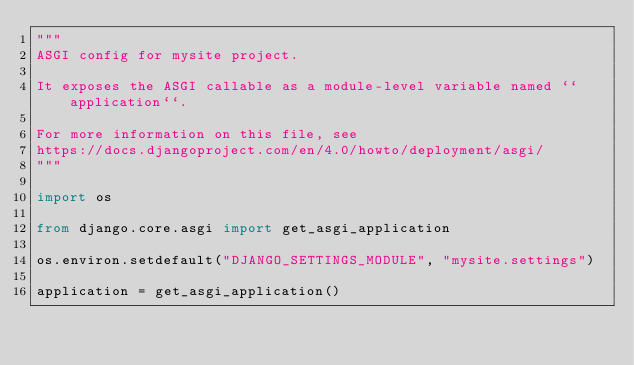Convert code to text. <code><loc_0><loc_0><loc_500><loc_500><_Python_>"""
ASGI config for mysite project.

It exposes the ASGI callable as a module-level variable named ``application``.

For more information on this file, see
https://docs.djangoproject.com/en/4.0/howto/deployment/asgi/
"""

import os

from django.core.asgi import get_asgi_application

os.environ.setdefault("DJANGO_SETTINGS_MODULE", "mysite.settings")

application = get_asgi_application()
</code> 